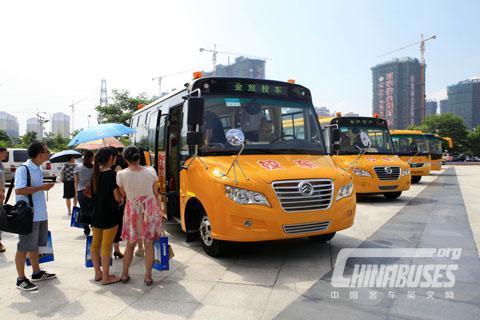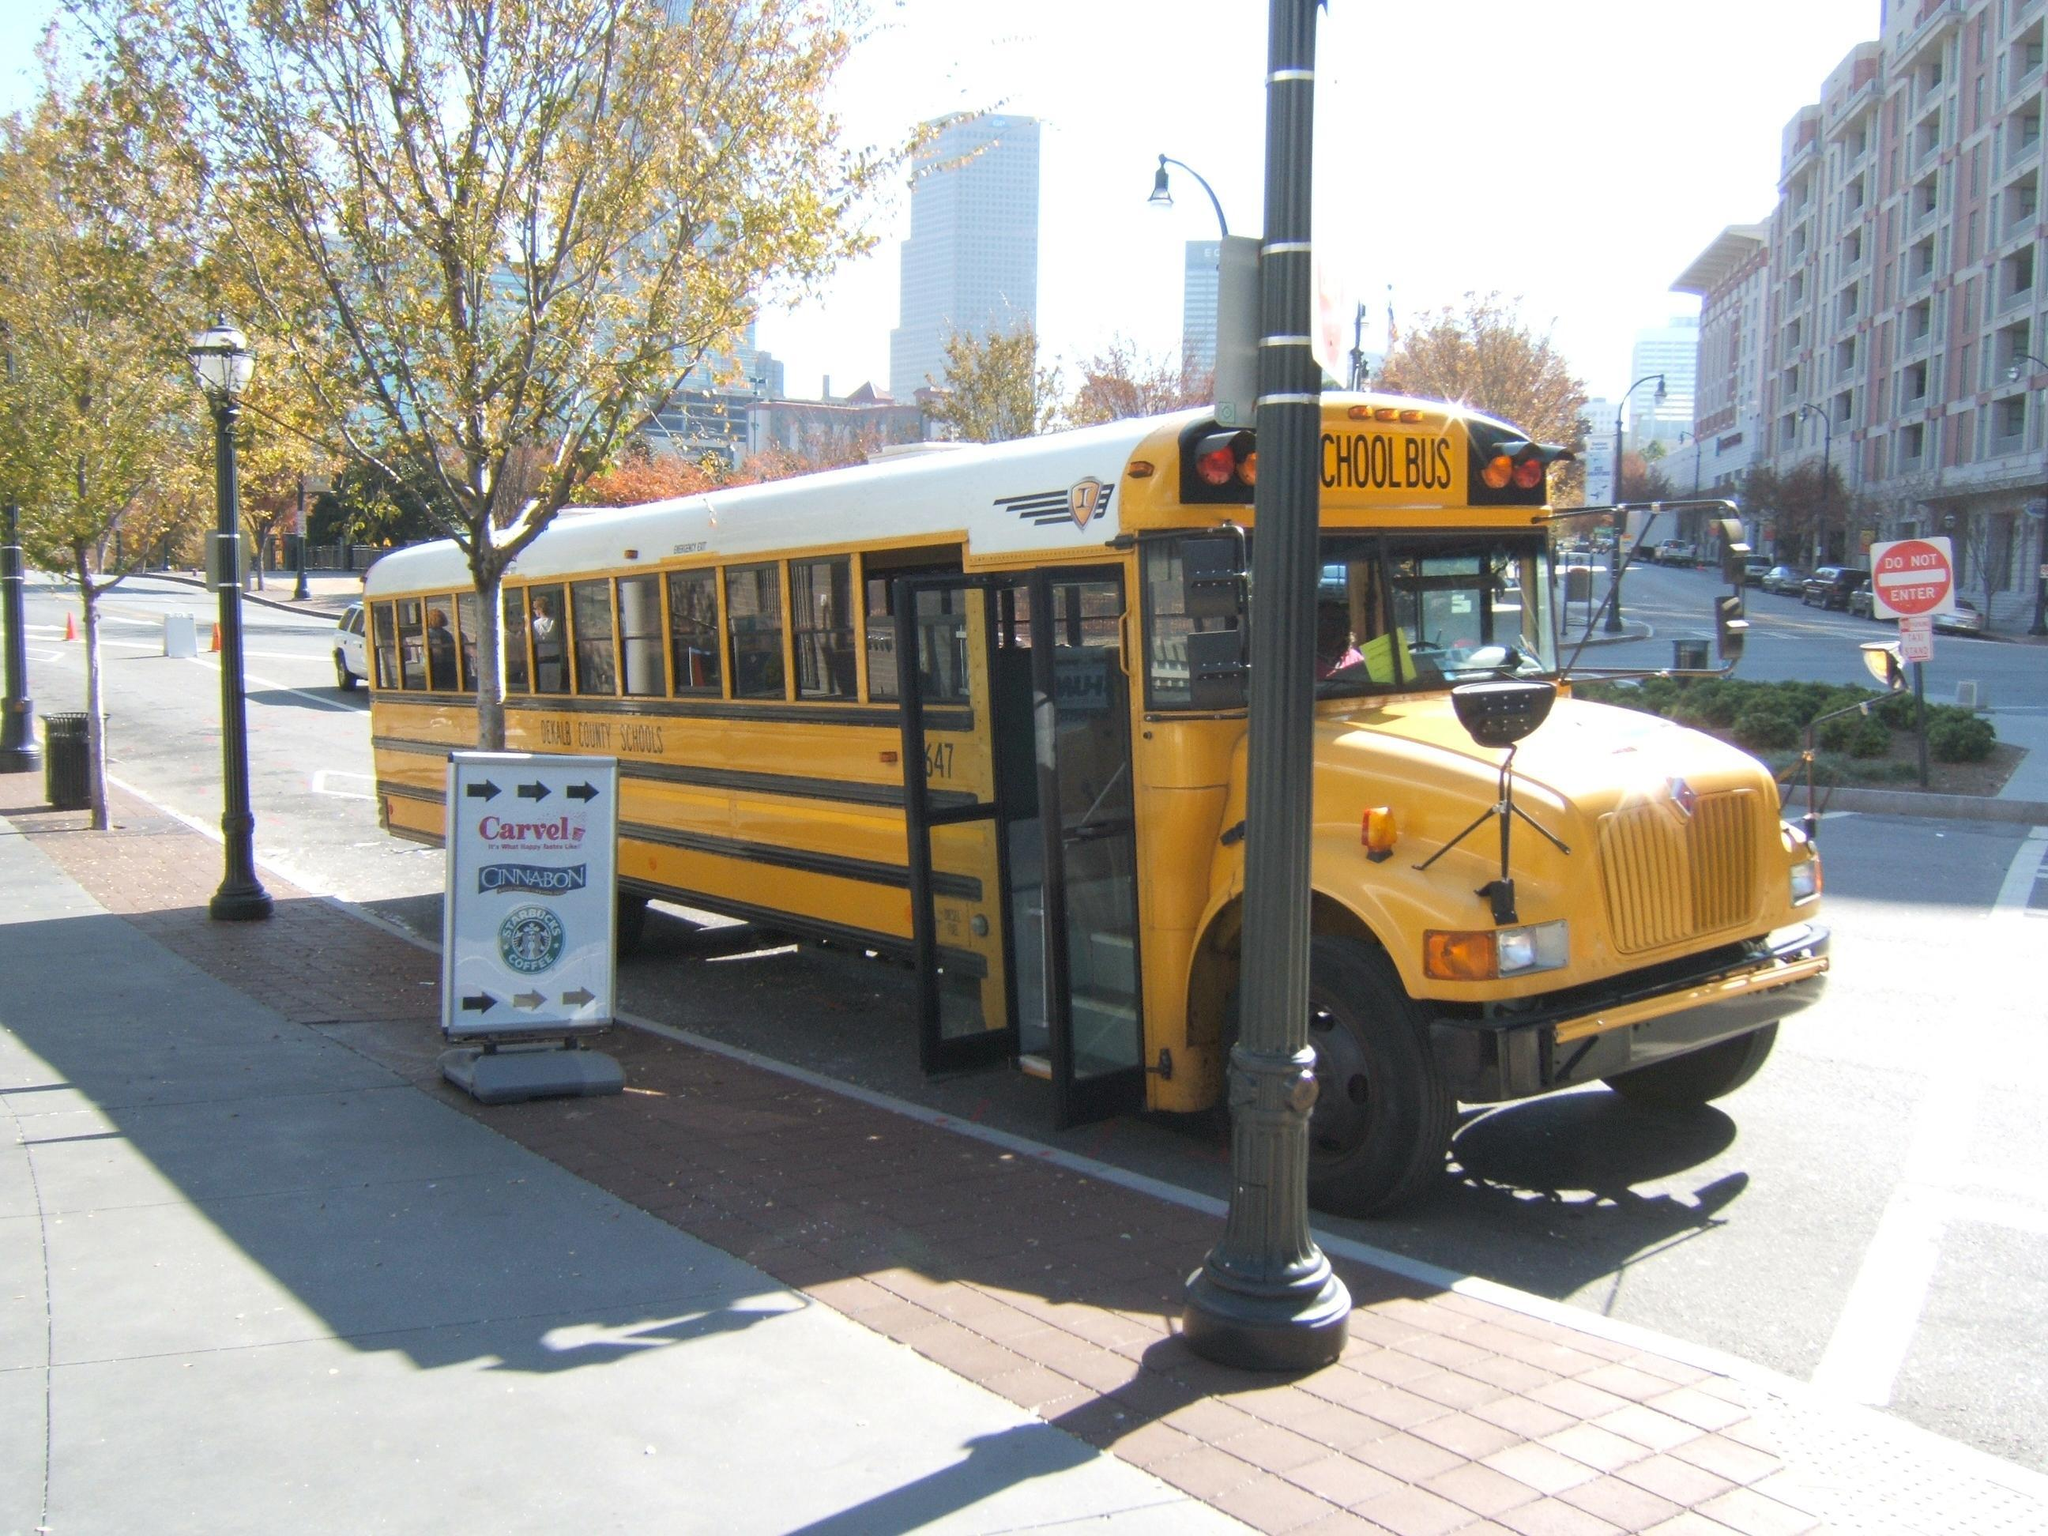The first image is the image on the left, the second image is the image on the right. Assess this claim about the two images: "In one image there is a single schoolbus that has been involved in an accident and is wrecked in the center of the image.". Correct or not? Answer yes or no. No. The first image is the image on the left, the second image is the image on the right. For the images shown, is this caption "One image shows a bus decorated with some type of 'artwork', and the other image shows a bus with severe impact damage on its front end." true? Answer yes or no. No. 